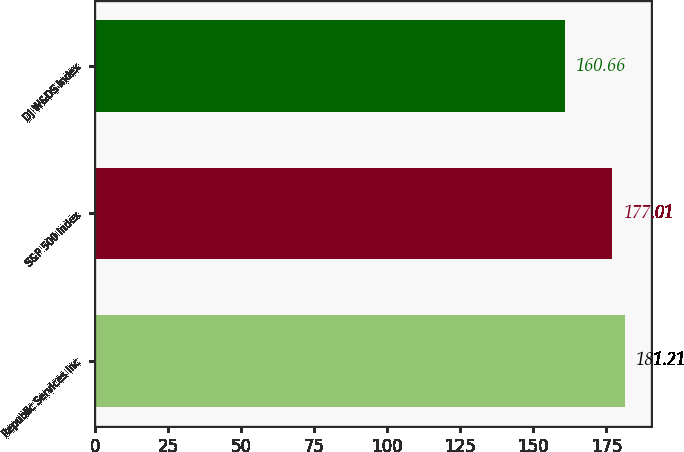<chart> <loc_0><loc_0><loc_500><loc_500><bar_chart><fcel>Republic Services Inc<fcel>S&P 500 Index<fcel>DJ W&DS Index<nl><fcel>181.21<fcel>177.01<fcel>160.66<nl></chart> 